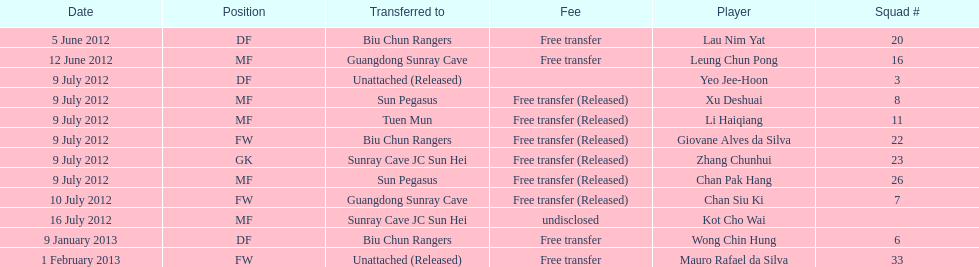Who is the first player listed? Lau Nim Yat. 